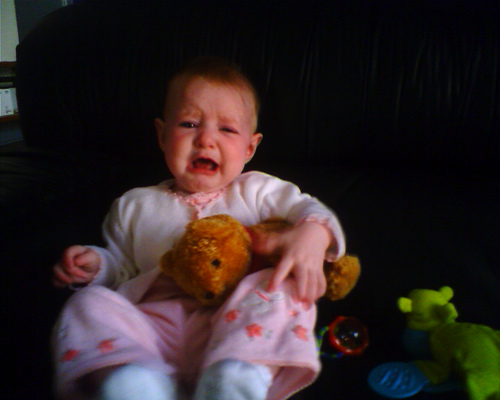What colors can be seen in the setting around the little girl? The setting around the little girl displays a mainly dark color scheme, with a black couch in the background. The high chair cover is light colored, providing a contrast, and there are toys in bright green and blue nearby. 